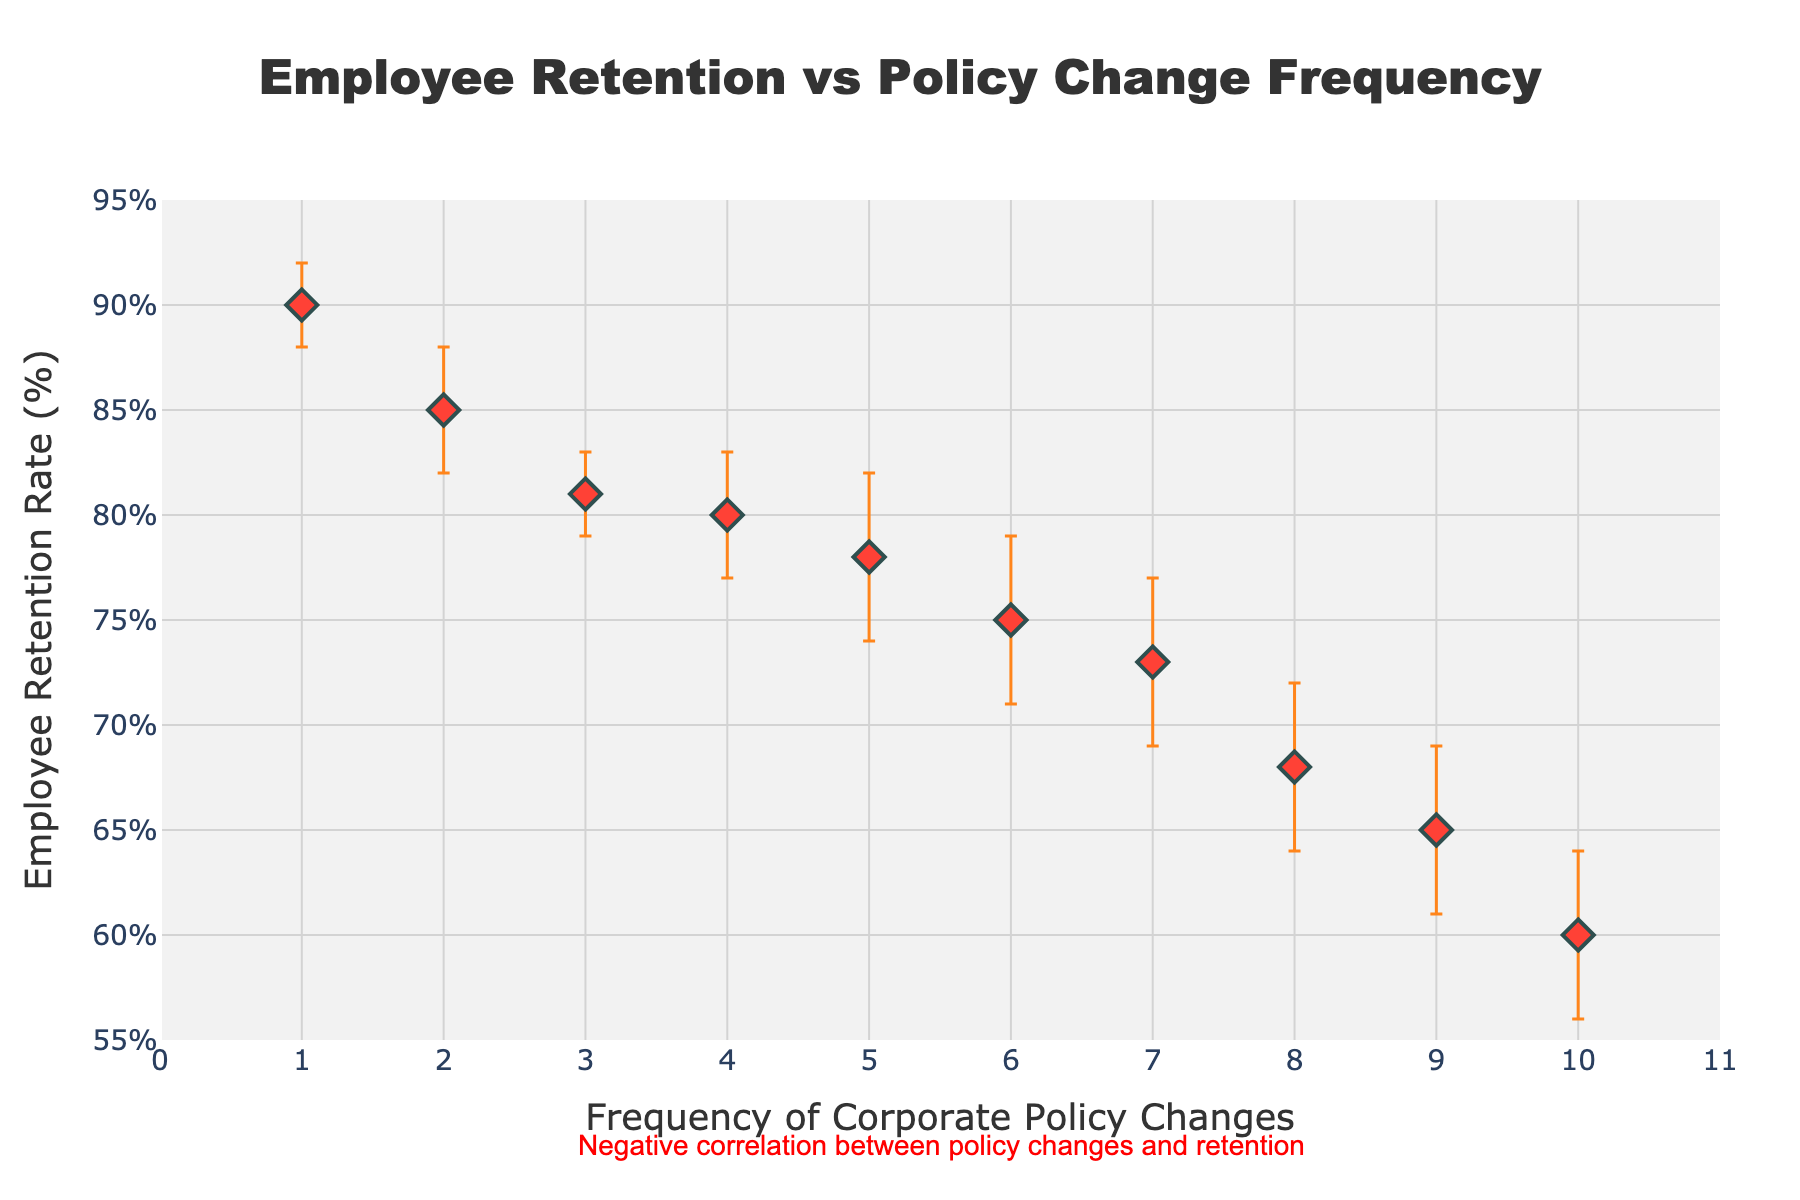How many data points are plotted in the scatter plot? To find the number of data points, we can count the markers on the scatter plot. Understanding this helps in assessing the completeness of the data representation.
Answer: 10 What is the title of the scatter plot? The title of the plot provides a summary of the data being visualized, which is usually found at the top of the figure. It helps in quickly understanding the overall content of the graph.
Answer: Employee Retention vs Policy Change Frequency What is the color of the markers used in the scatter plot? Observing the color of the markers helps in distinguishing the plotted data points.
Answer: Red What is the y-axis label of the scatter plot? The y-axis label indicates what the vertical axis represents, which in this case is necessary to understand the measure being plotted on that axis.
Answer: Employee Retention Rate (%) Which data point has the highest retention rate? To find the data point with the highest retention rate, compare the y-values of all points and identify the maximum value.
Answer: Policy Change Frequency = 1 What is the retention rate for a company with a policy change frequency of 8? To answer this, locate the data point where the x-axis value is 8 and read the corresponding y-axis value.
Answer: 68% Which data point has the largest error bar? Error bars represent uncertainty and the length of them can be visually compared; the longest one represents the largest uncertainty.
Answer: Policy Change Frequency = 5 Is there a visible trend between the frequency of policy changes and employee retention rates? By observing the scatter plot, check if there is a general upward or downward trend in the data points. This helps determine the relationship between the two variables.
Answer: There is a negative correlation What is the difference in retention rate between policy change frequencies of 2 and 10? For this compositional question, find the retention rate for frequencies 2 and 10 and subtract the smaller one from the larger one to show the difference.
Answer: 25% How does the retention rate change when the policy change frequency increases from 4 to 6? Compare the retention rates at x = 6 and x = 4 to determine the change. This usually involves finding the amount by which one value is greater than or lesser than the other.
Answer: Decreases by 5% 